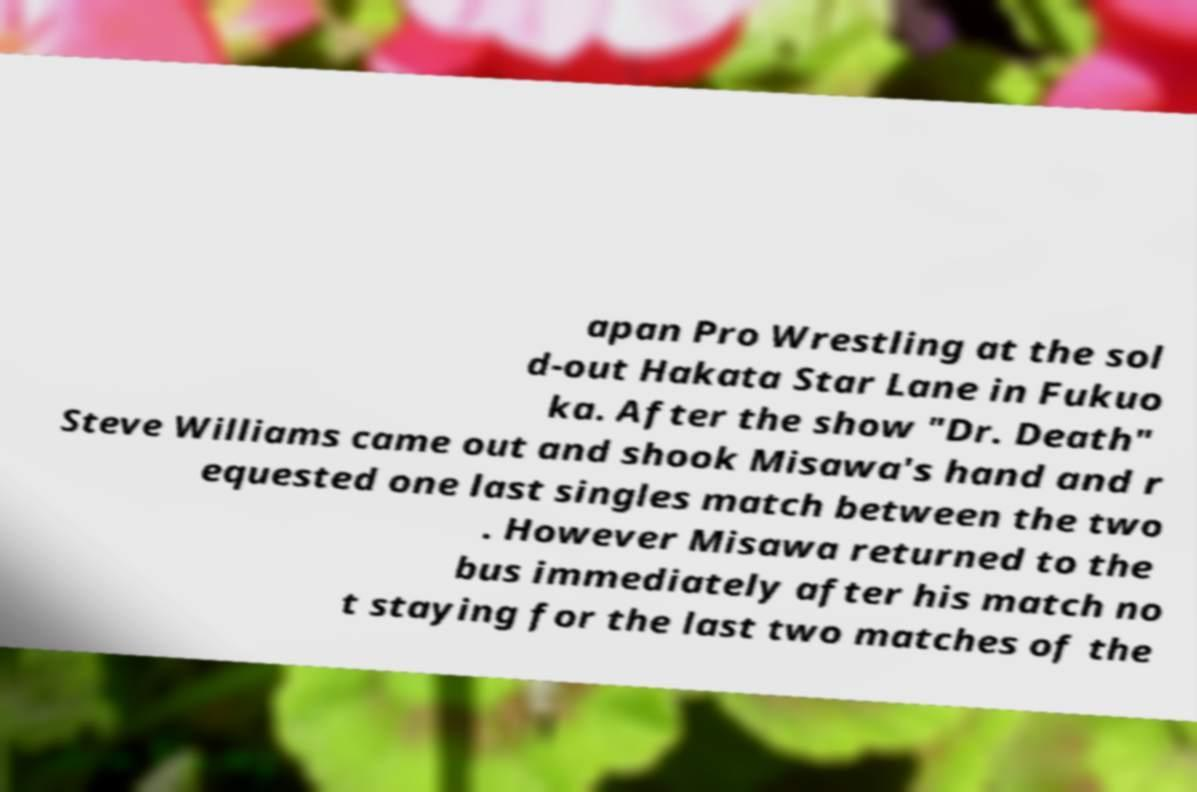Could you assist in decoding the text presented in this image and type it out clearly? apan Pro Wrestling at the sol d-out Hakata Star Lane in Fukuo ka. After the show "Dr. Death" Steve Williams came out and shook Misawa's hand and r equested one last singles match between the two . However Misawa returned to the bus immediately after his match no t staying for the last two matches of the 